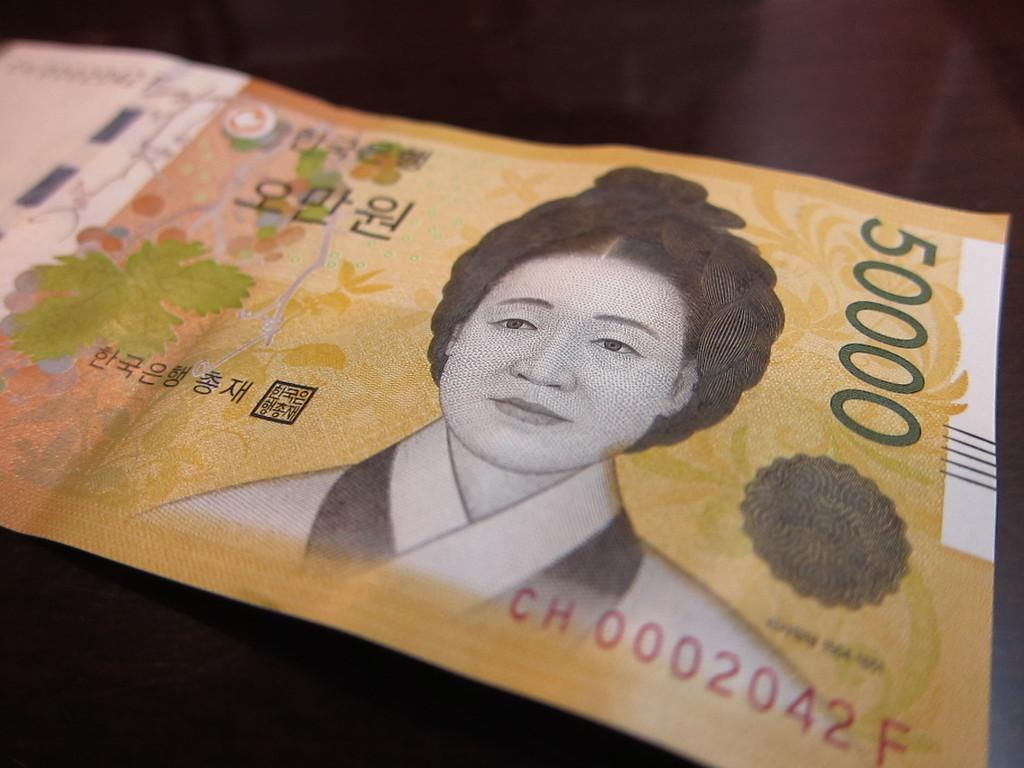Could you give a brief overview of what you see in this image? In the picture there is a currency note, on the currency note there is some text and there is a picture of a person present. 